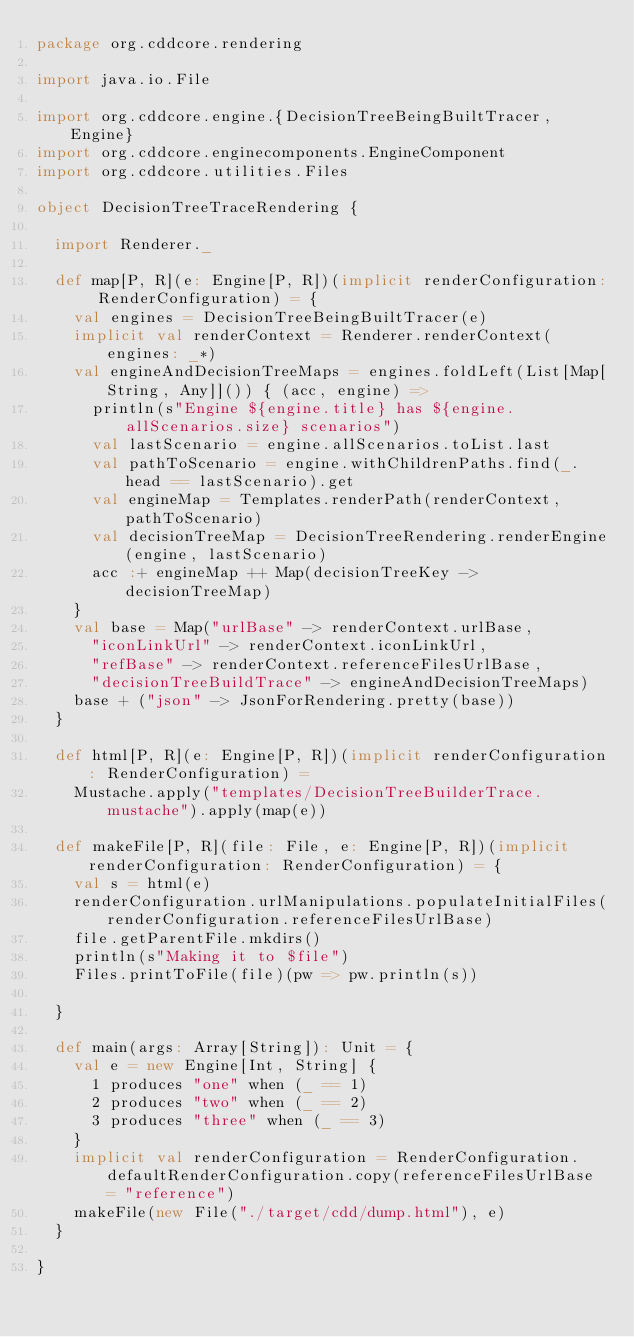Convert code to text. <code><loc_0><loc_0><loc_500><loc_500><_Scala_>package org.cddcore.rendering

import java.io.File

import org.cddcore.engine.{DecisionTreeBeingBuiltTracer, Engine}
import org.cddcore.enginecomponents.EngineComponent
import org.cddcore.utilities.Files

object DecisionTreeTraceRendering {

  import Renderer._

  def map[P, R](e: Engine[P, R])(implicit renderConfiguration: RenderConfiguration) = {
    val engines = DecisionTreeBeingBuiltTracer(e)
    implicit val renderContext = Renderer.renderContext(engines: _*)
    val engineAndDecisionTreeMaps = engines.foldLeft(List[Map[String, Any]]()) { (acc, engine) =>
      println(s"Engine ${engine.title} has ${engine.allScenarios.size} scenarios")
      val lastScenario = engine.allScenarios.toList.last
      val pathToScenario = engine.withChildrenPaths.find(_.head == lastScenario).get
      val engineMap = Templates.renderPath(renderContext, pathToScenario)
      val decisionTreeMap = DecisionTreeRendering.renderEngine(engine, lastScenario)
      acc :+ engineMap ++ Map(decisionTreeKey -> decisionTreeMap)
    }
    val base = Map("urlBase" -> renderContext.urlBase,
      "iconLinkUrl" -> renderContext.iconLinkUrl,
      "refBase" -> renderContext.referenceFilesUrlBase,
      "decisionTreeBuildTrace" -> engineAndDecisionTreeMaps)
    base + ("json" -> JsonForRendering.pretty(base))
  }

  def html[P, R](e: Engine[P, R])(implicit renderConfiguration: RenderConfiguration) =
    Mustache.apply("templates/DecisionTreeBuilderTrace.mustache").apply(map(e))

  def makeFile[P, R](file: File, e: Engine[P, R])(implicit renderConfiguration: RenderConfiguration) = {
    val s = html(e)
    renderConfiguration.urlManipulations.populateInitialFiles(renderConfiguration.referenceFilesUrlBase)
    file.getParentFile.mkdirs()
    println(s"Making it to $file")
    Files.printToFile(file)(pw => pw.println(s))

  }

  def main(args: Array[String]): Unit = {
    val e = new Engine[Int, String] {
      1 produces "one" when (_ == 1)
      2 produces "two" when (_ == 2)
      3 produces "three" when (_ == 3)
    }
    implicit val renderConfiguration = RenderConfiguration.defaultRenderConfiguration.copy(referenceFilesUrlBase = "reference")
    makeFile(new File("./target/cdd/dump.html"), e)
  }

}
</code> 